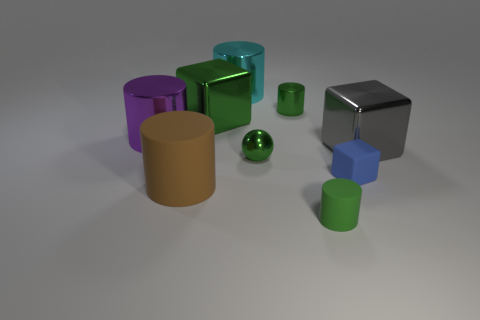Subtract all cylinders. How many objects are left? 4 Subtract all cyan metal objects. Subtract all tiny green rubber objects. How many objects are left? 7 Add 6 blue things. How many blue things are left? 7 Add 8 shiny balls. How many shiny balls exist? 9 Subtract all cyan cylinders. How many cylinders are left? 4 Subtract all big gray metallic blocks. How many blocks are left? 2 Subtract 1 blue blocks. How many objects are left? 8 Subtract 4 cylinders. How many cylinders are left? 1 Subtract all gray cubes. Subtract all green cylinders. How many cubes are left? 2 Subtract all brown blocks. How many brown balls are left? 0 